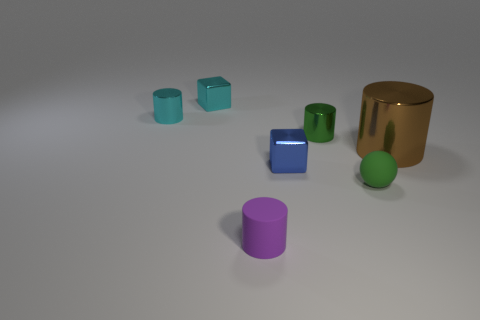Is there any other thing that has the same shape as the small purple object?
Give a very brief answer. Yes. Does the blue metal thing have the same size as the cyan cylinder?
Keep it short and to the point. Yes. What material is the thing right of the rubber thing that is behind the small cylinder in front of the sphere made of?
Keep it short and to the point. Metal. Are there the same number of large brown metallic cylinders left of the blue shiny block and big purple metallic things?
Offer a terse response. Yes. Is there anything else that is the same size as the blue shiny cube?
Keep it short and to the point. Yes. What number of things are small blue cubes or blocks?
Provide a short and direct response. 2. There is a tiny cyan object that is the same material as the small cyan cylinder; what is its shape?
Your answer should be very brief. Cube. What size is the cylinder to the left of the cylinder that is in front of the green matte object?
Ensure brevity in your answer.  Small. How many small things are green cylinders or cyan metal cubes?
Your answer should be compact. 2. What number of other objects are the same color as the large metal thing?
Your response must be concise. 0. 